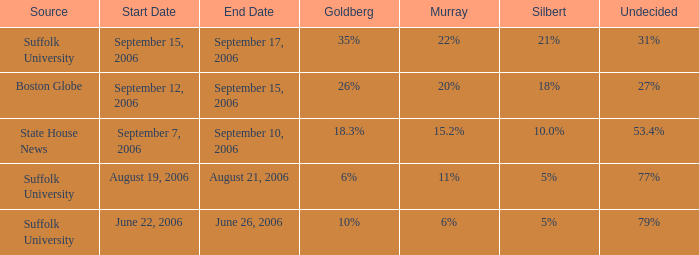I'm looking to parse the entire table for insights. Could you assist me with that? {'header': ['Source', 'Start Date', 'End Date', 'Goldberg', 'Murray', 'Silbert', 'Undecided'], 'rows': [['Suffolk University', 'September 15, 2006', 'September 17, 2006', '35%', '22%', '21%', '31%'], ['Boston Globe', 'September 12, 2006', 'September 15, 2006', '26%', '20%', '18%', '27%'], ['State House News', 'September 7, 2006', 'September 10, 2006', '18.3%', '15.2%', '10.0%', '53.4%'], ['Suffolk University', 'August 19, 2006', 'August 21, 2006', '6%', '11%', '5%', '77%'], ['Suffolk University', 'June 22, 2006', 'June 26, 2006', '10%', '6%', '5%', '79%']]} What is the date of the poll with Silbert at 18%? September 12–15, 2006. 